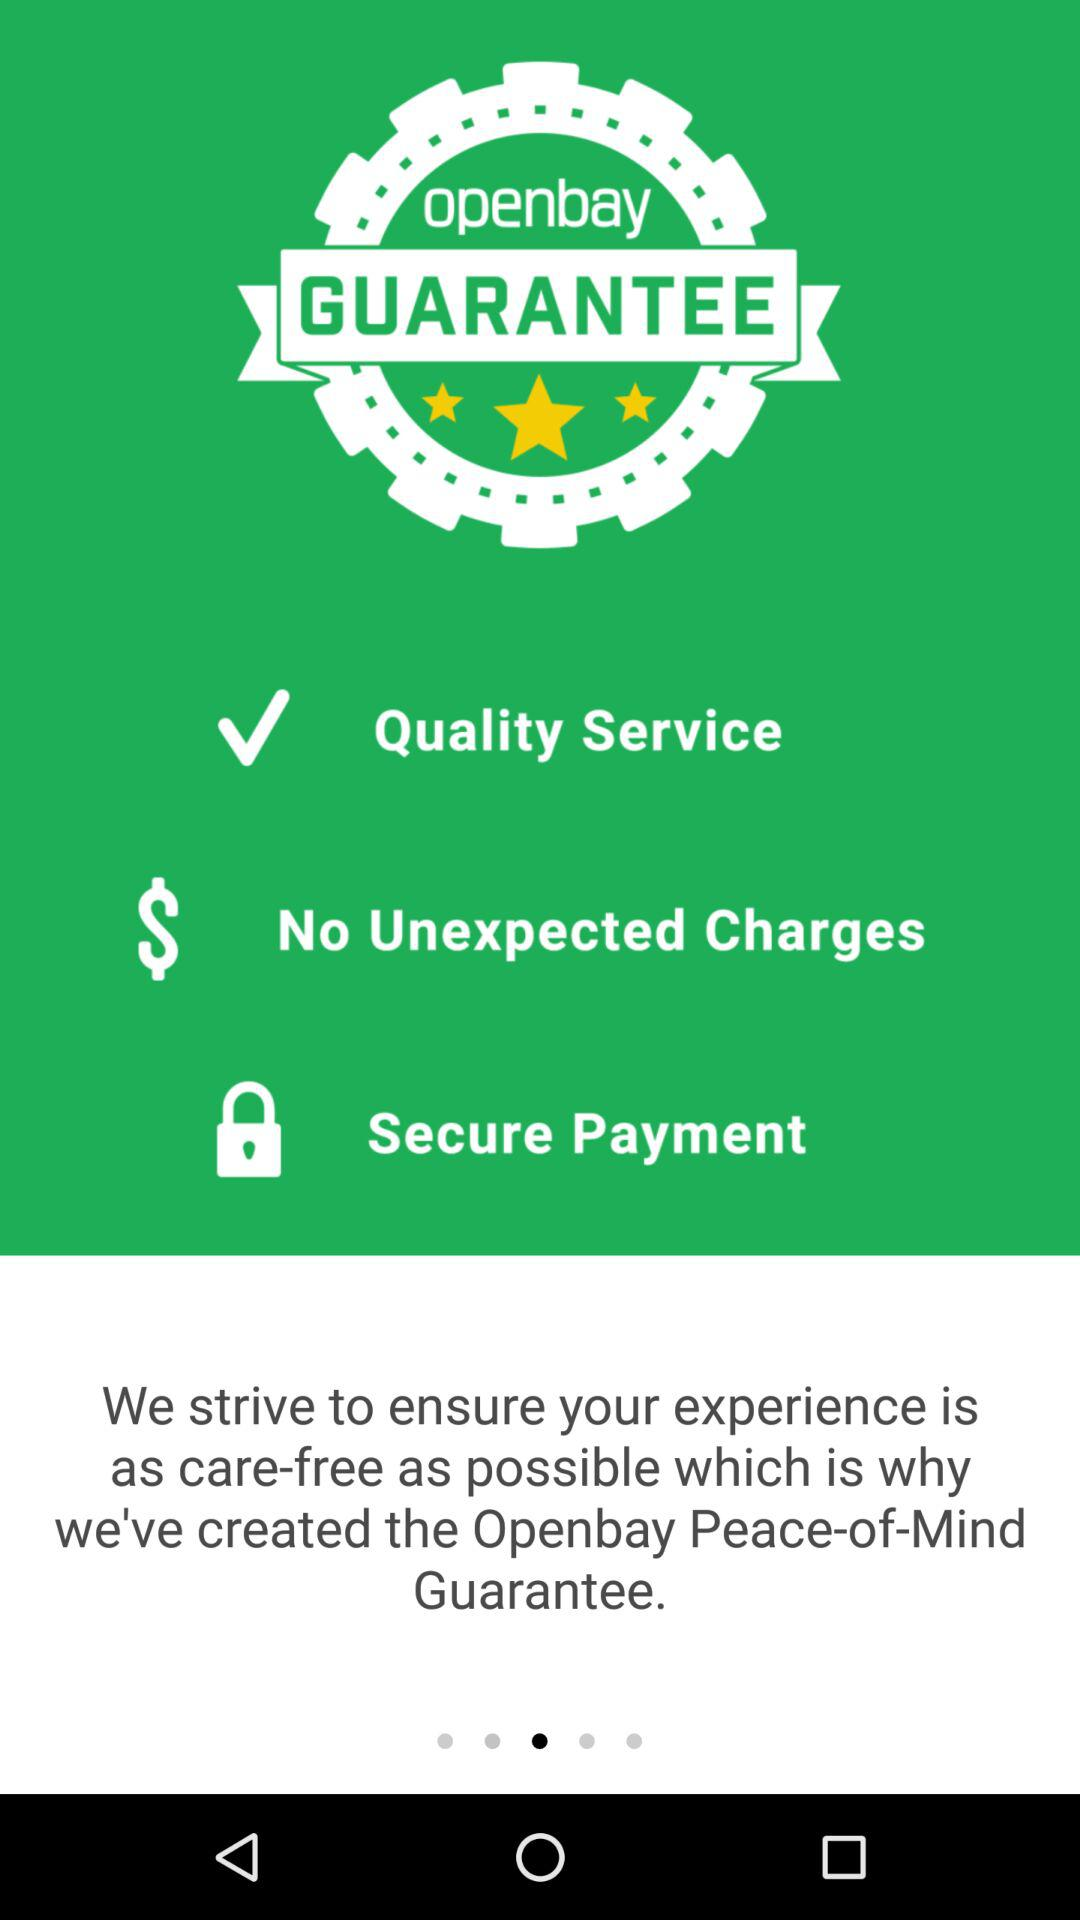How many guarantees are there?
Answer the question using a single word or phrase. 3 